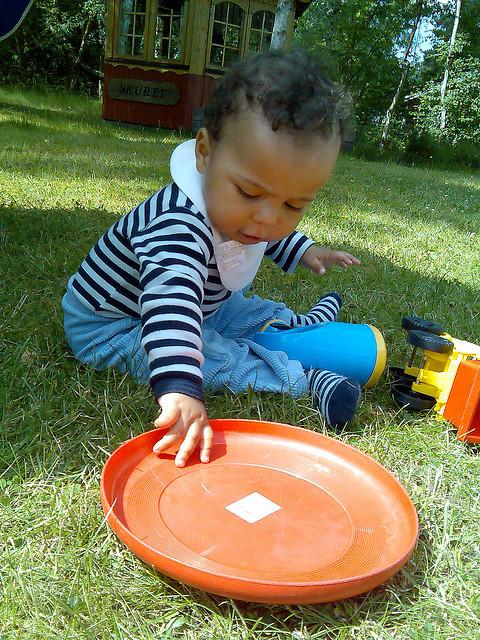What kind of toy is to the right?
Short answer required. Truck. Is the child old enough to play frisbee?
Concise answer only. No. How many kids are there?
Concise answer only. 1. 